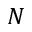Convert formula to latex. <formula><loc_0><loc_0><loc_500><loc_500>N</formula> 